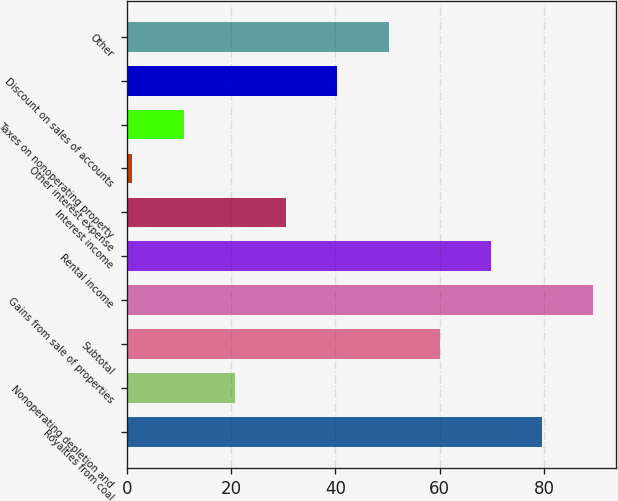<chart> <loc_0><loc_0><loc_500><loc_500><bar_chart><fcel>Royalties from coal<fcel>Nonoperating depletion and<fcel>Subtotal<fcel>Gains from sale of properties<fcel>Rental income<fcel>Interest income<fcel>Other interest expense<fcel>Taxes on nonoperating property<fcel>Discount on sales of accounts<fcel>Other<nl><fcel>79.6<fcel>20.8<fcel>60<fcel>89.4<fcel>69.8<fcel>30.6<fcel>1<fcel>11<fcel>40.4<fcel>50.2<nl></chart> 